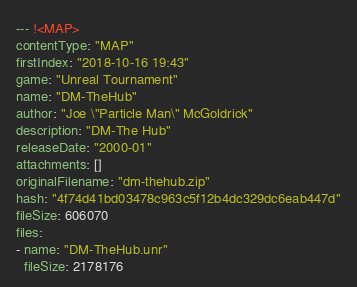Convert code to text. <code><loc_0><loc_0><loc_500><loc_500><_YAML_>--- !<MAP>
contentType: "MAP"
firstIndex: "2018-10-16 19:43"
game: "Unreal Tournament"
name: "DM-TheHub"
author: "Joe \"Particle Man\" McGoldrick"
description: "DM-The Hub"
releaseDate: "2000-01"
attachments: []
originalFilename: "dm-thehub.zip"
hash: "4f74d41bd03478c963c5f12b4dc329dc6eab447d"
fileSize: 606070
files:
- name: "DM-TheHub.unr"
  fileSize: 2178176</code> 